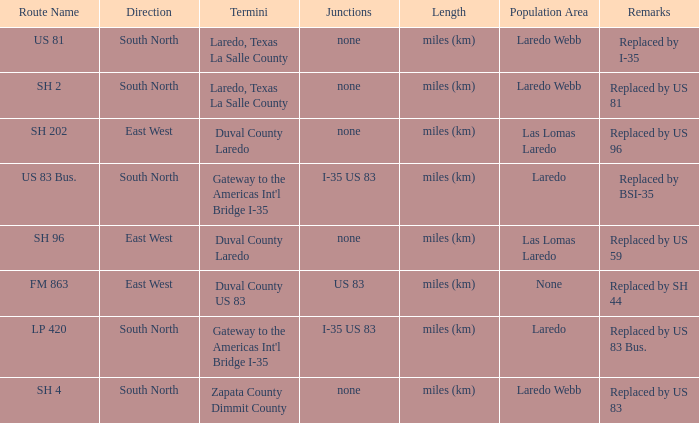Which junctions have "replaced by bsi-35" listed in their remarks section? I-35 US 83. 